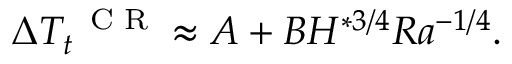Convert formula to latex. <formula><loc_0><loc_0><loc_500><loc_500>\Delta T _ { t } ^ { C R } \approx A + B H ^ { * 3 / 4 } R a ^ { - 1 / 4 } .</formula> 